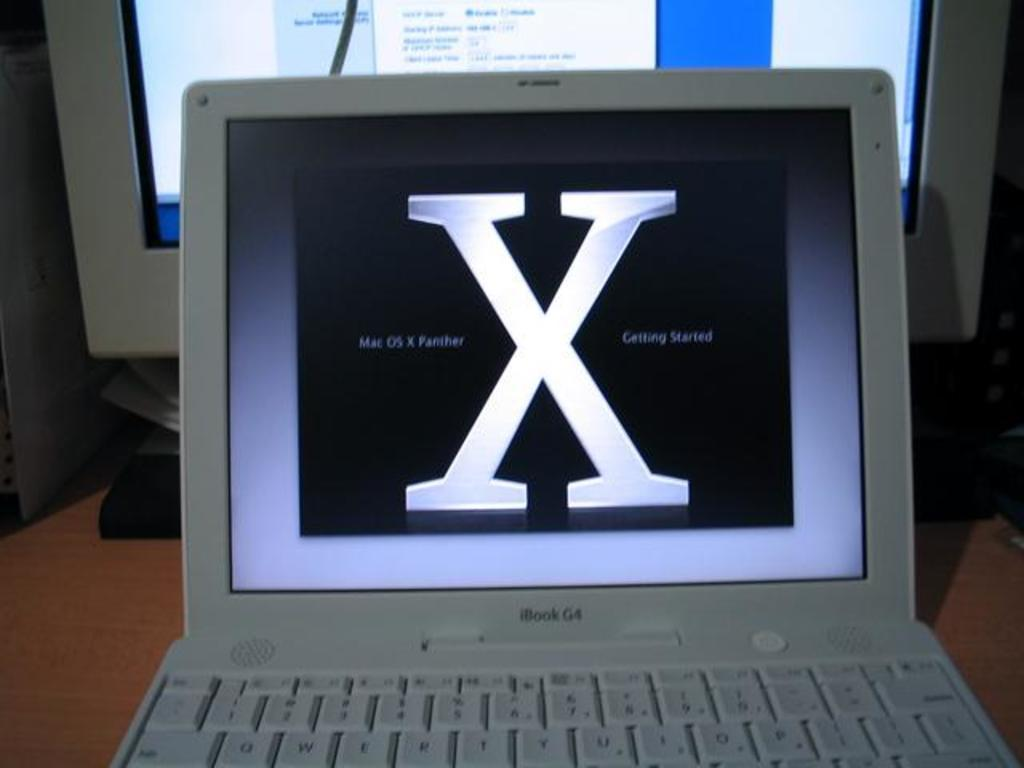<image>
Provide a brief description of the given image. ibook g4 with mac os x panther on black screen 